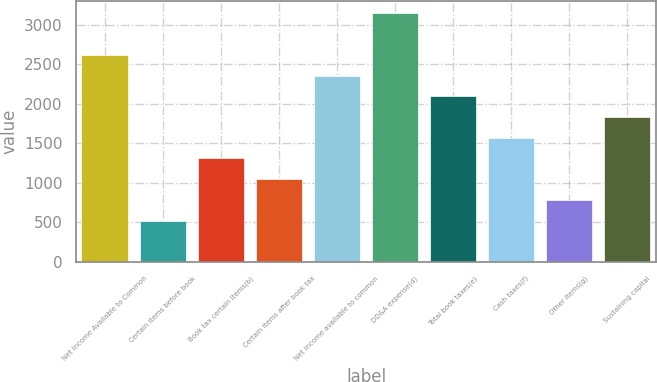Convert chart. <chart><loc_0><loc_0><loc_500><loc_500><bar_chart><fcel>Net Income Available to Common<fcel>Certain items before book<fcel>Book tax certain items(b)<fcel>Certain items after book tax<fcel>Net income available to common<fcel>DD&A expense(d)<fcel>Total book taxes(e)<fcel>Cash taxes(f)<fcel>Other items(g)<fcel>Sustaining capital<nl><fcel>2618.04<fcel>525<fcel>1309.89<fcel>1048.26<fcel>2356.41<fcel>3141.3<fcel>2094.78<fcel>1571.52<fcel>786.63<fcel>1833.15<nl></chart> 